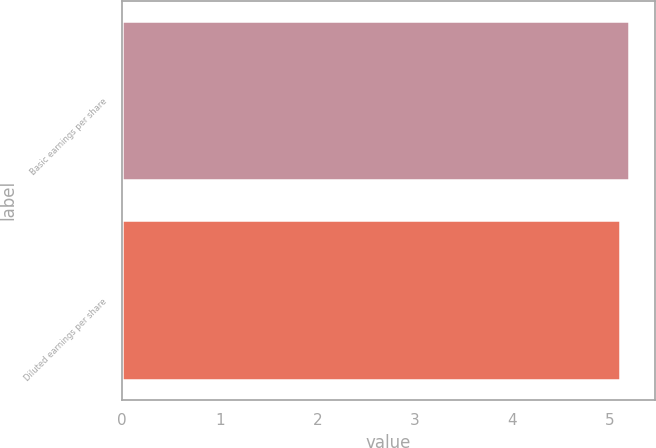<chart> <loc_0><loc_0><loc_500><loc_500><bar_chart><fcel>Basic earnings per share<fcel>Diluted earnings per share<nl><fcel>5.2<fcel>5.11<nl></chart> 